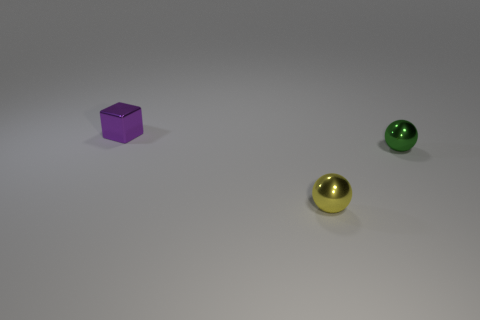Subtract all yellow balls. How many balls are left? 1 Add 1 yellow shiny balls. How many objects exist? 4 Add 1 tiny objects. How many tiny objects exist? 4 Subtract 0 brown cylinders. How many objects are left? 3 Subtract all cubes. How many objects are left? 2 Subtract all brown spheres. Subtract all purple cubes. How many spheres are left? 2 Subtract all green cylinders. Subtract all small yellow objects. How many objects are left? 2 Add 2 tiny cubes. How many tiny cubes are left? 3 